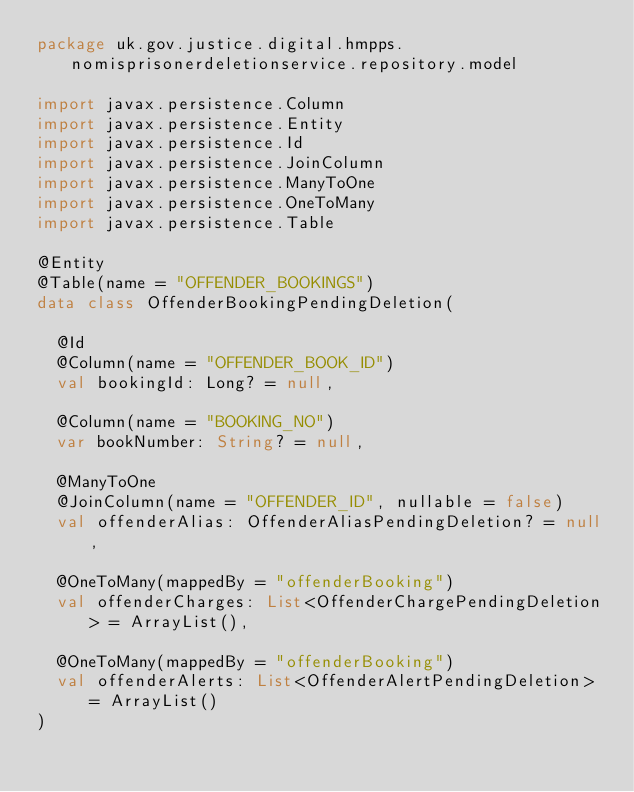<code> <loc_0><loc_0><loc_500><loc_500><_Kotlin_>package uk.gov.justice.digital.hmpps.nomisprisonerdeletionservice.repository.model

import javax.persistence.Column
import javax.persistence.Entity
import javax.persistence.Id
import javax.persistence.JoinColumn
import javax.persistence.ManyToOne
import javax.persistence.OneToMany
import javax.persistence.Table

@Entity
@Table(name = "OFFENDER_BOOKINGS")
data class OffenderBookingPendingDeletion(

  @Id
  @Column(name = "OFFENDER_BOOK_ID")
  val bookingId: Long? = null,

  @Column(name = "BOOKING_NO")
  var bookNumber: String? = null,

  @ManyToOne
  @JoinColumn(name = "OFFENDER_ID", nullable = false)
  val offenderAlias: OffenderAliasPendingDeletion? = null,

  @OneToMany(mappedBy = "offenderBooking")
  val offenderCharges: List<OffenderChargePendingDeletion> = ArrayList(),

  @OneToMany(mappedBy = "offenderBooking")
  val offenderAlerts: List<OffenderAlertPendingDeletion> = ArrayList()
)
</code> 